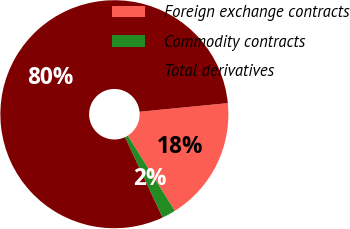Convert chart to OTSL. <chart><loc_0><loc_0><loc_500><loc_500><pie_chart><fcel>Foreign exchange contracts<fcel>Commodity contracts<fcel>Total derivatives<nl><fcel>17.65%<fcel>1.96%<fcel>80.39%<nl></chart> 